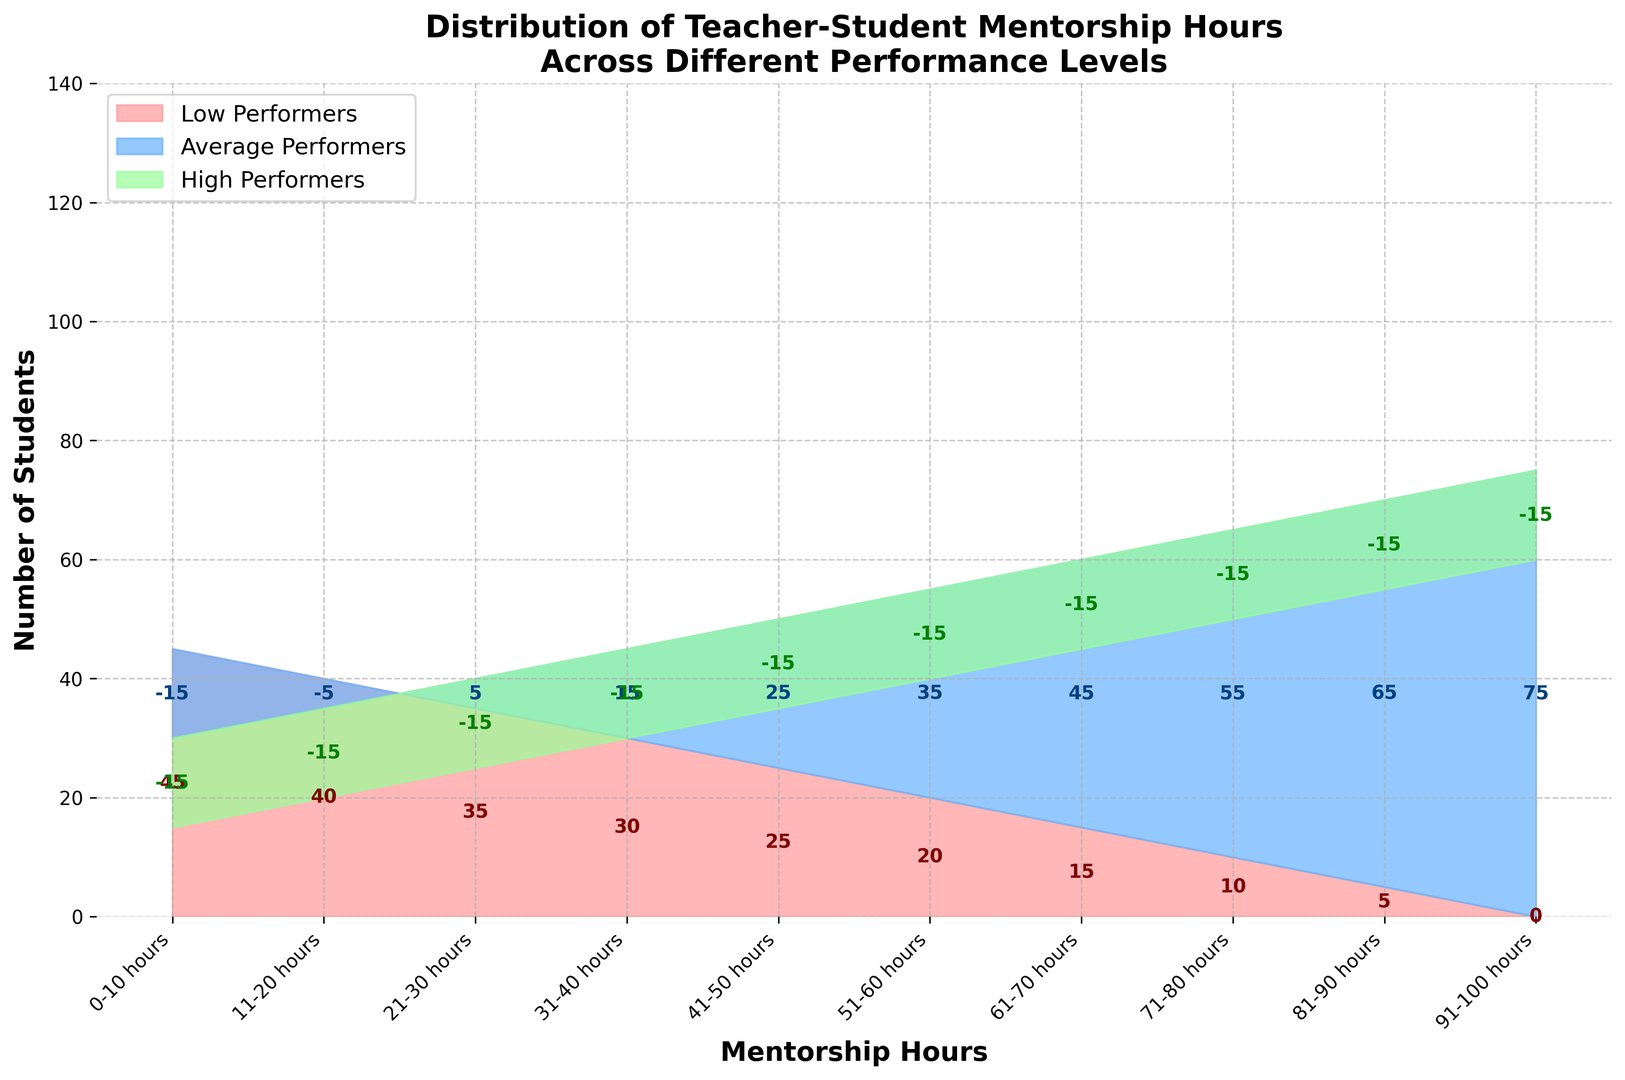What is the number of low performers receiving between 0-10 hours of mentorship? Look at the leftmost section of the red area in the chart where it begins. The value at 0-10 hours for low performers reads 45.
Answer: 45 How does the number of average performers change from the group receiving 0-10 hours to those receiving 11-20 hours of mentorship? Move from the first blue segment (0-10 hours) to the second one (11-20 hours). The values change from 30 to 35. Therefore, the number of average performers increases by 5.
Answer: Increases by 5 Among high performers, at which mentorship hour interval do the number of students first surpass 40? Observe the green areas. Notice that the high performers first surpass 40 at the interval of 61-70 hours.
Answer: 61-70 hours What's the difference in the number of students between low performers at 0-10 hours and high performers at the 91-100 hours? Find the corresponding areas. Low performers at 0-10 hours are 45, and high performers at 91-100 hours are 60. The difference is 60 - 45.
Answer: 15 At which mentorship hour interval do average performers surpass both low and high performers? Review the three areas and find the interval where the blue area is above both red and green. This occurs at 41-50 hours.
Answer: 41-50 hours How does the number of students receiving 51-60 hours of mentorship compare to 21-30 hours for low performers? Look at the points on the red area at these intervals, 51-60 hours has 20 low performers and 21-30 hours has 35. Therefore, 21-30 hours has 15 more students.
Answer: 21-30 hours is higher by 15 If you sum the number of high performers at the 31-40 hour interval to the number of low performers at 71-80 hours, what is the result? Number of high performers at 31-40 hours is 30 and low performers at 71-80 hours is 10. Summing them gives 30 + 10.
Answer: 40 By how much does the number of low performers decrease from 0-10 hours to 91-100 hours? Look at the values for low performers at these intervals: 0-10 hours has 45 and 91-100 hours has 0. The decrease is 45 - 0.
Answer: 45 What is the total number of students in the 51-60 hour interval? Add the number of students in each performance level: low performers (20) + average performers (55) + high performers (40). This totals 20 + 55 + 40.
Answer: 115 